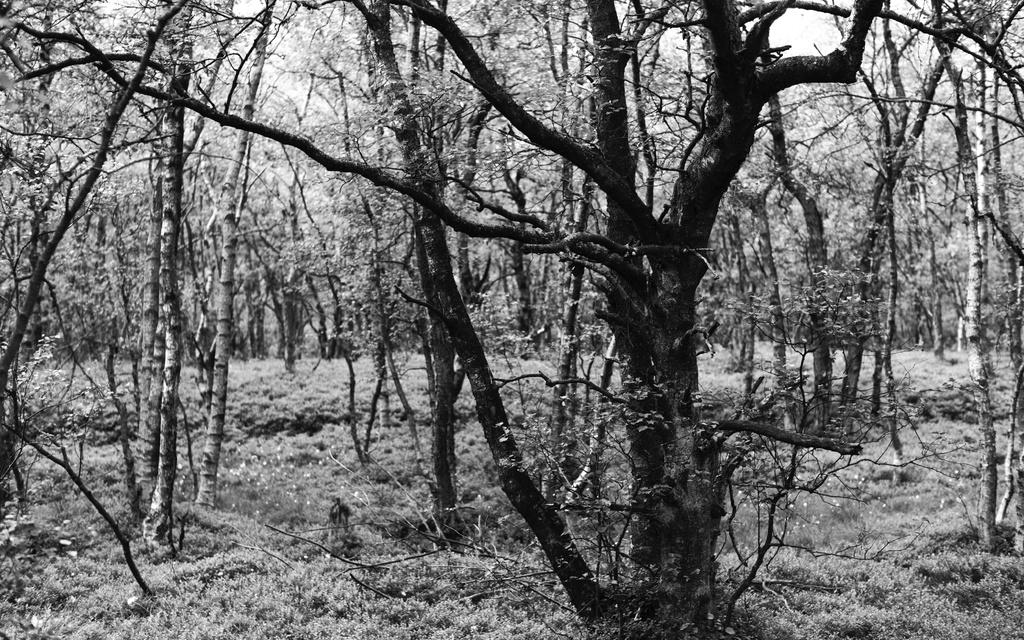What type of vegetation can be seen in the image? There are trees in the image. What is the color scheme of the image? The image is in black and white mode. What book is being read by the tree in the image? There is no book or tree reading a book in the image, as it only features trees and is in black and white mode. 